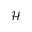<formula> <loc_0><loc_0><loc_500><loc_500>\mathcal { H }</formula> 